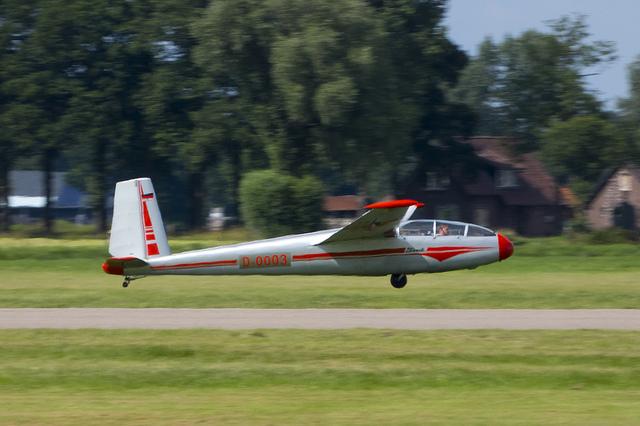Is the plane taking off?
Answer briefly. Yes. Is this an urban area?
Be succinct. No. Did the plane just land?
Keep it brief. No. What colors are the plane?
Be succinct. Gray and red. Is the plane flying?
Give a very brief answer. Yes. How many wheels are on this plane?
Keep it brief. 2. 